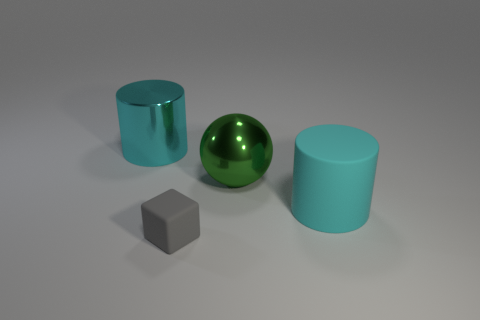Are the large green thing and the small cube made of the same material?
Offer a very short reply. No. There is a cylinder behind the large rubber cylinder; are there any cyan cylinders that are on the left side of it?
Provide a short and direct response. No. How many things are to the left of the green metallic sphere and behind the tiny rubber block?
Give a very brief answer. 1. The big cyan object that is right of the large cyan metal cylinder has what shape?
Keep it short and to the point. Cylinder. How many other rubber things are the same size as the gray rubber object?
Offer a very short reply. 0. Is the color of the large cylinder that is in front of the cyan shiny object the same as the big shiny cylinder?
Give a very brief answer. Yes. There is a large thing that is both behind the big matte thing and right of the tiny matte thing; what material is it?
Your answer should be very brief. Metal. Are there more small rubber objects than large metallic things?
Offer a terse response. No. What color is the cylinder that is to the right of the big cyan thing left of the cyan object that is to the right of the cyan shiny cylinder?
Provide a short and direct response. Cyan. Is the material of the large thing that is on the left side of the big shiny ball the same as the gray block?
Offer a terse response. No. 